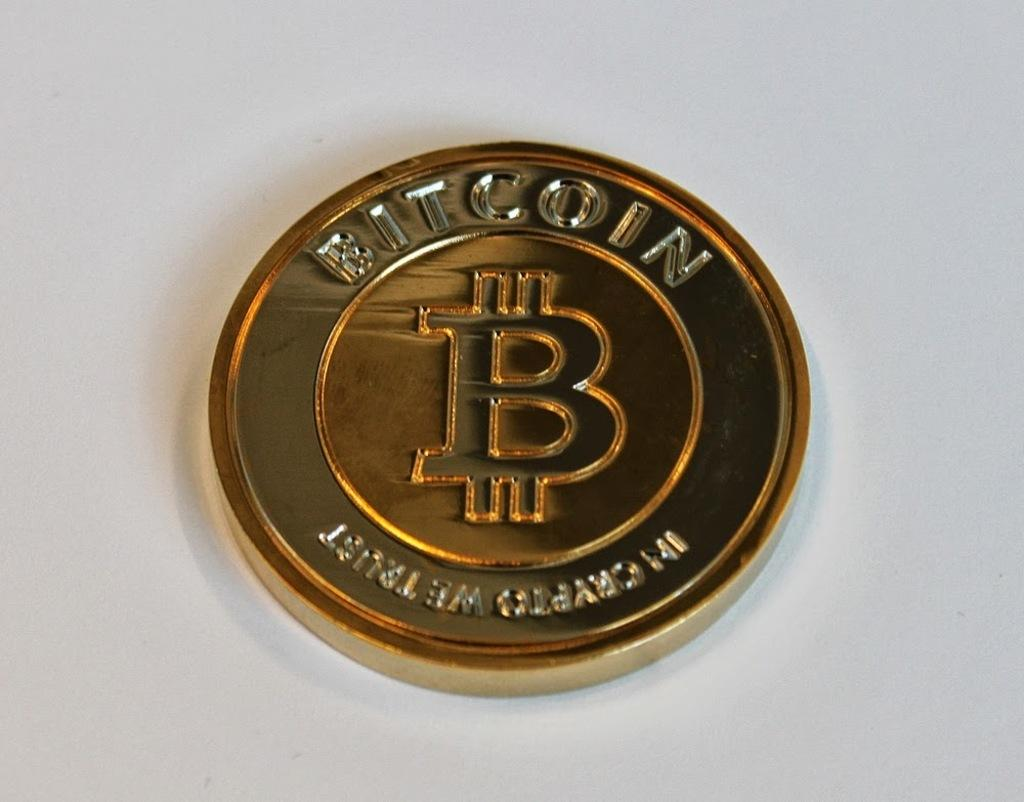<image>
Describe the image concisely. a coin that has a symbol on it and says 'bitcoin' at the top 